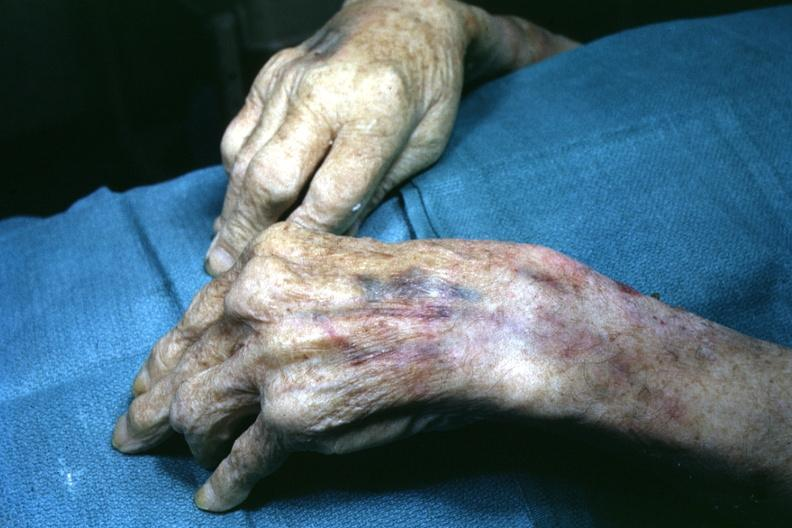s coronary artery present?
Answer the question using a single word or phrase. No 